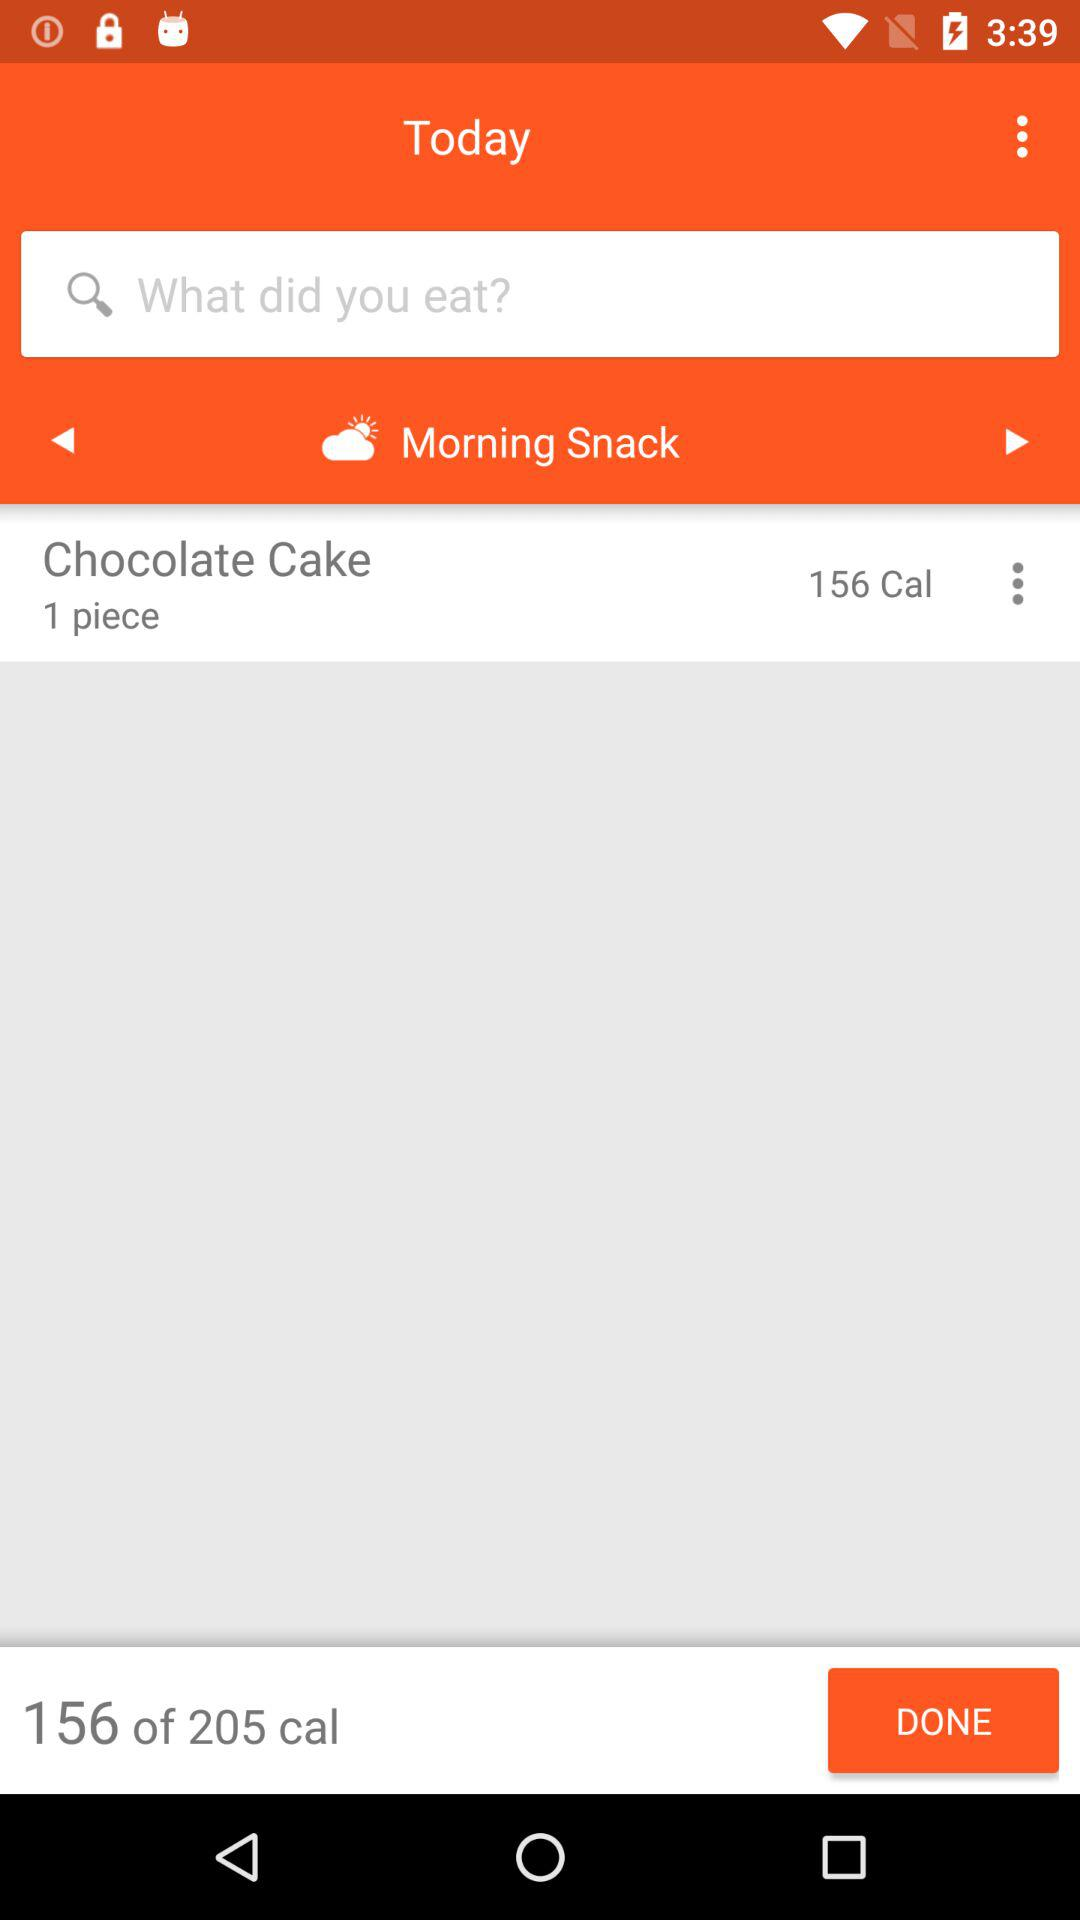How many pieces of chocolate cake did I eat?
Answer the question using a single word or phrase. 1 